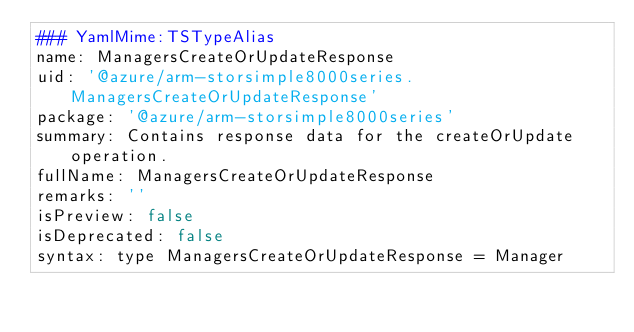Convert code to text. <code><loc_0><loc_0><loc_500><loc_500><_YAML_>### YamlMime:TSTypeAlias
name: ManagersCreateOrUpdateResponse
uid: '@azure/arm-storsimple8000series.ManagersCreateOrUpdateResponse'
package: '@azure/arm-storsimple8000series'
summary: Contains response data for the createOrUpdate operation.
fullName: ManagersCreateOrUpdateResponse
remarks: ''
isPreview: false
isDeprecated: false
syntax: type ManagersCreateOrUpdateResponse = Manager
</code> 